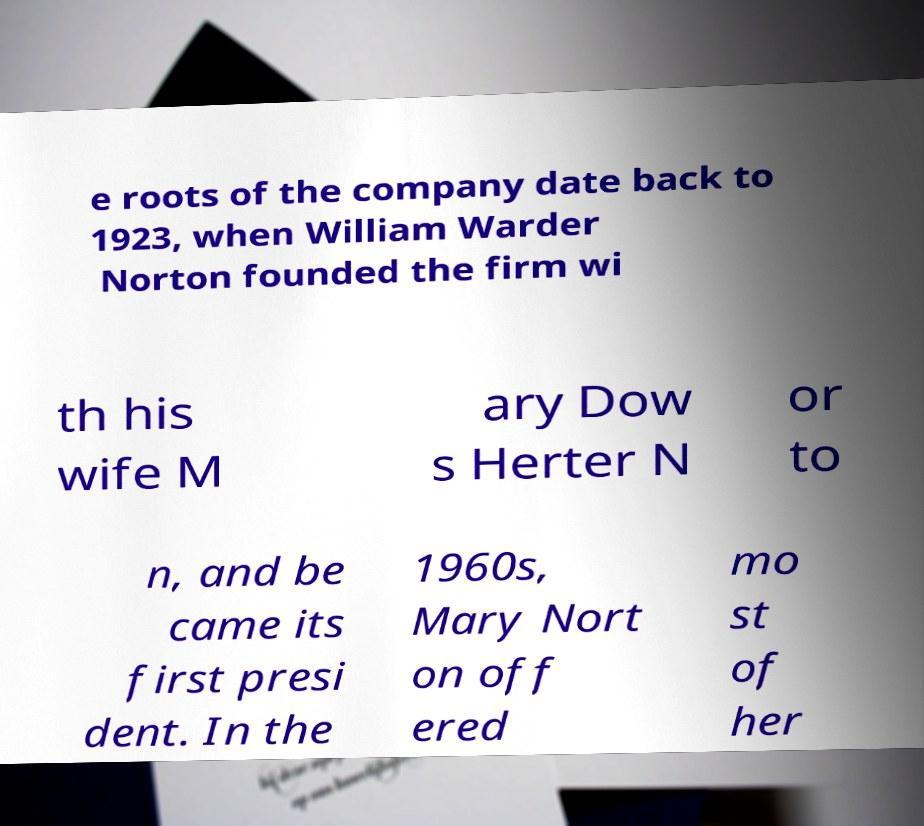What messages or text are displayed in this image? I need them in a readable, typed format. e roots of the company date back to 1923, when William Warder Norton founded the firm wi th his wife M ary Dow s Herter N or to n, and be came its first presi dent. In the 1960s, Mary Nort on off ered mo st of her 